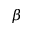Convert formula to latex. <formula><loc_0><loc_0><loc_500><loc_500>\beta</formula> 